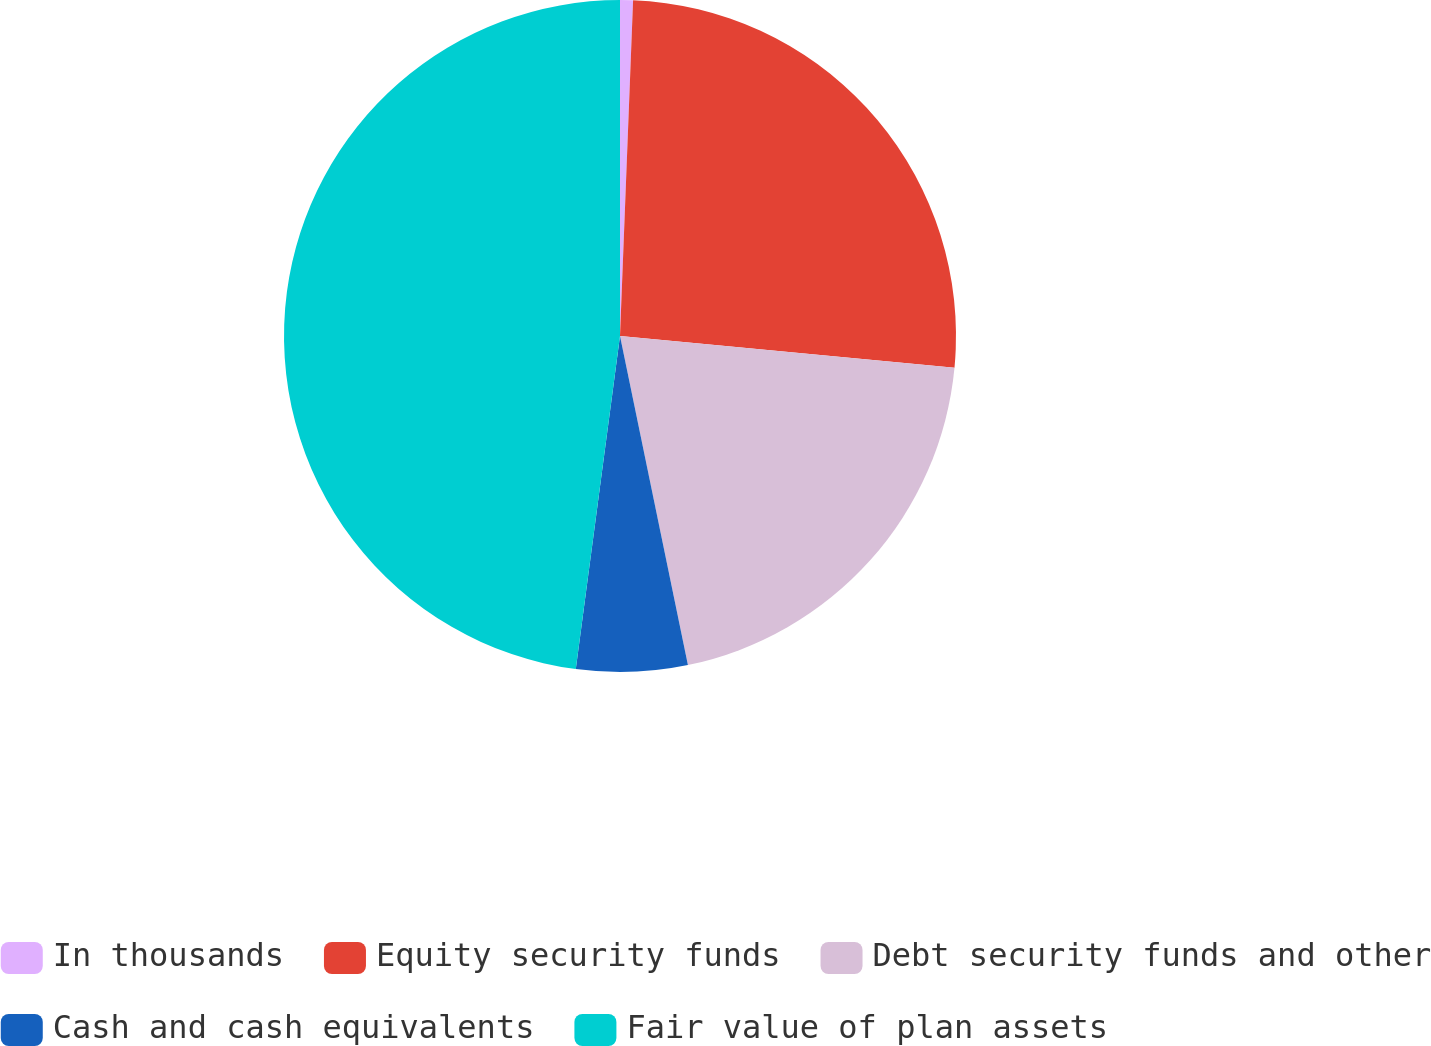Convert chart to OTSL. <chart><loc_0><loc_0><loc_500><loc_500><pie_chart><fcel>In thousands<fcel>Equity security funds<fcel>Debt security funds and other<fcel>Cash and cash equivalents<fcel>Fair value of plan assets<nl><fcel>0.62%<fcel>25.89%<fcel>20.25%<fcel>5.34%<fcel>47.9%<nl></chart> 